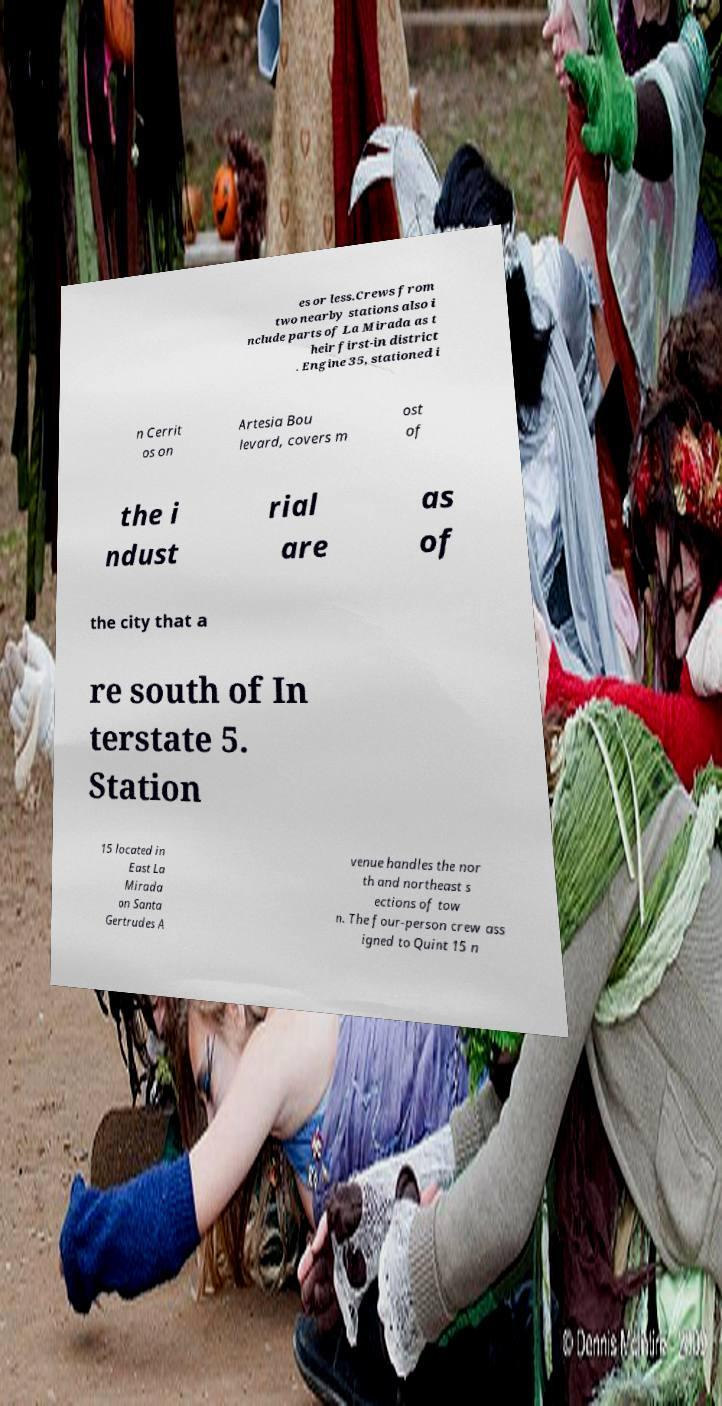I need the written content from this picture converted into text. Can you do that? es or less.Crews from two nearby stations also i nclude parts of La Mirada as t heir first-in district . Engine 35, stationed i n Cerrit os on Artesia Bou levard, covers m ost of the i ndust rial are as of the city that a re south of In terstate 5. Station 15 located in East La Mirada on Santa Gertrudes A venue handles the nor th and northeast s ections of tow n. The four-person crew ass igned to Quint 15 n 